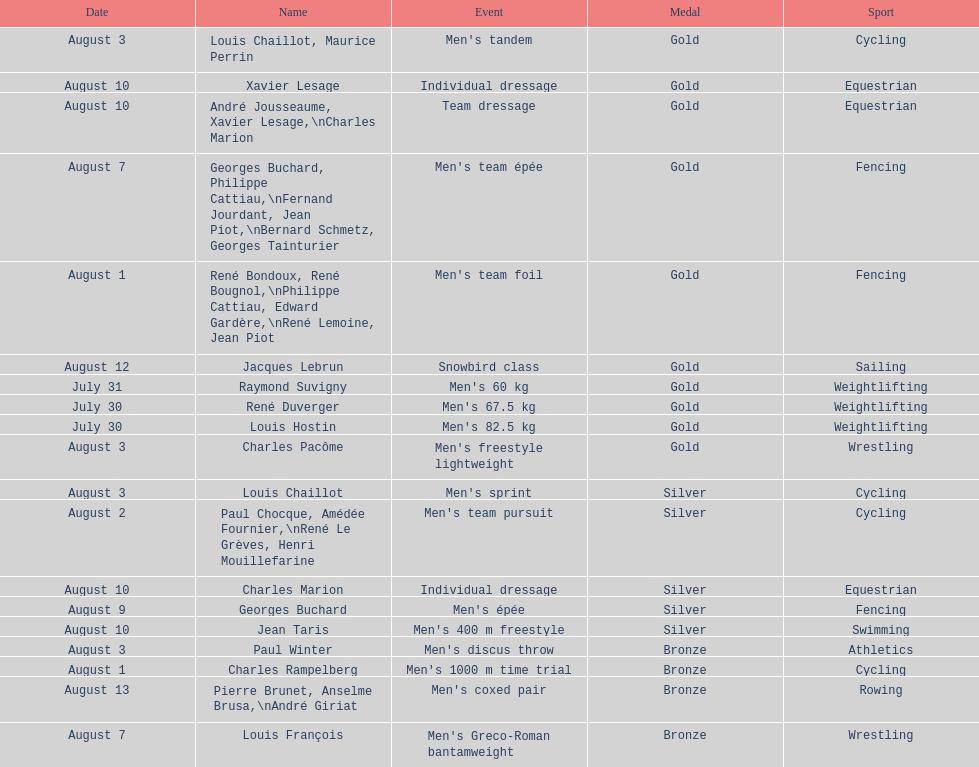How many gold medals did this country win during these olympics? 10. 